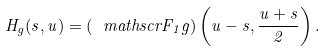Convert formula to latex. <formula><loc_0><loc_0><loc_500><loc_500>H _ { g } ( s , u ) = ( \ m a t h s c r F _ { 1 } g ) \left ( u - s , \frac { u + s } 2 \right ) .</formula> 